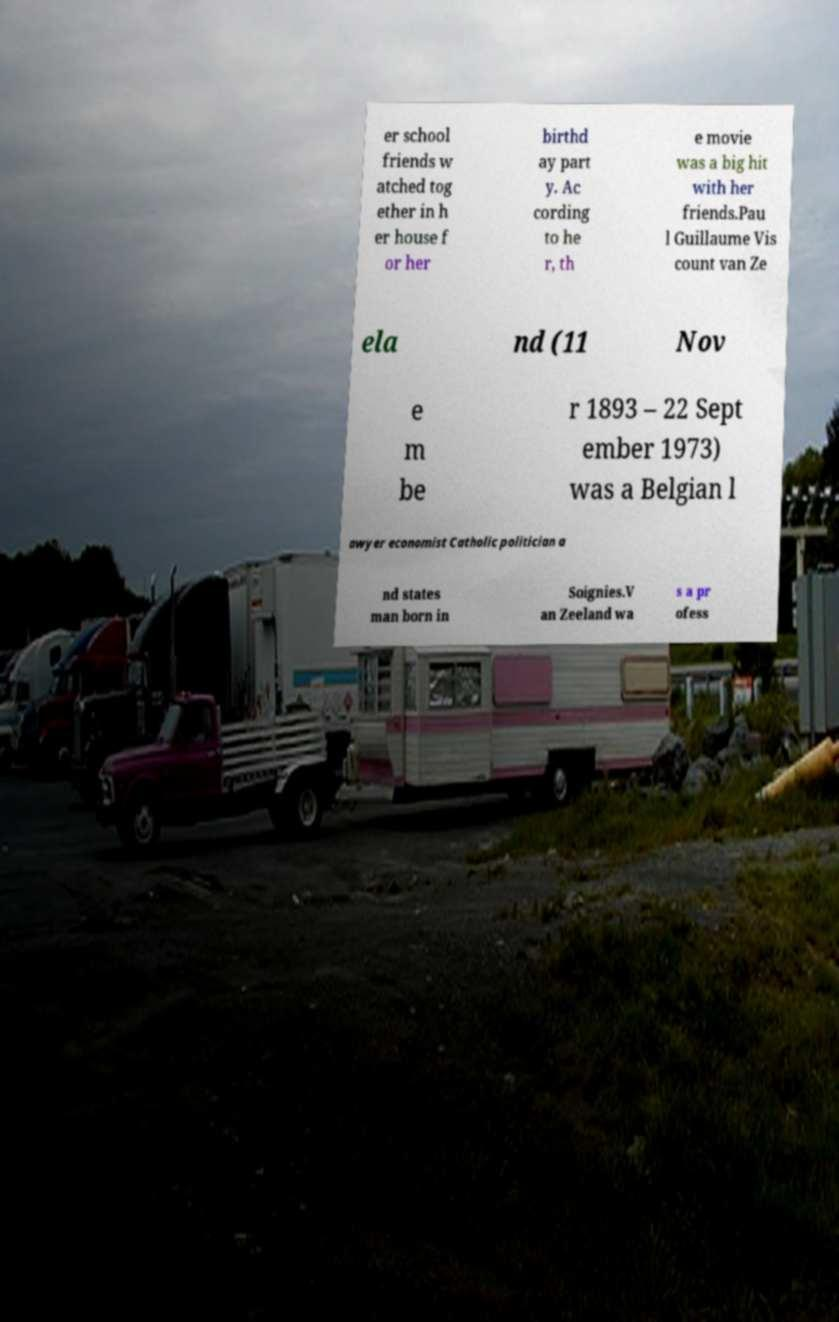Could you extract and type out the text from this image? er school friends w atched tog ether in h er house f or her birthd ay part y. Ac cording to he r, th e movie was a big hit with her friends.Pau l Guillaume Vis count van Ze ela nd (11 Nov e m be r 1893 – 22 Sept ember 1973) was a Belgian l awyer economist Catholic politician a nd states man born in Soignies.V an Zeeland wa s a pr ofess 